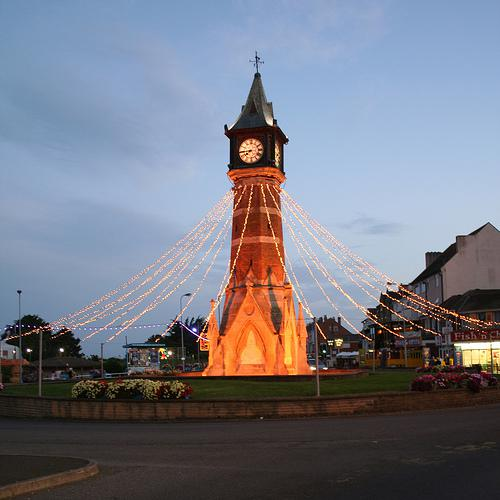Question: what appears at the very top of the tower?
Choices:
A. A flag.
B. A weathervane.
C. A sign.
D. An antenna.
Answer with the letter. Answer: B 